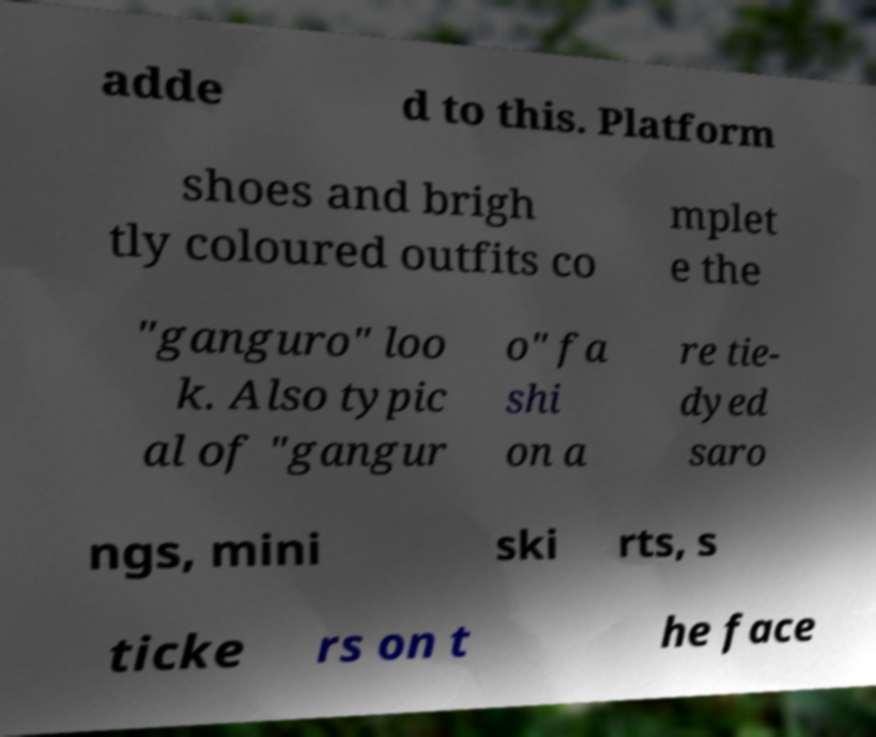Could you extract and type out the text from this image? adde d to this. Platform shoes and brigh tly coloured outfits co mplet e the "ganguro" loo k. Also typic al of "gangur o" fa shi on a re tie- dyed saro ngs, mini ski rts, s ticke rs on t he face 